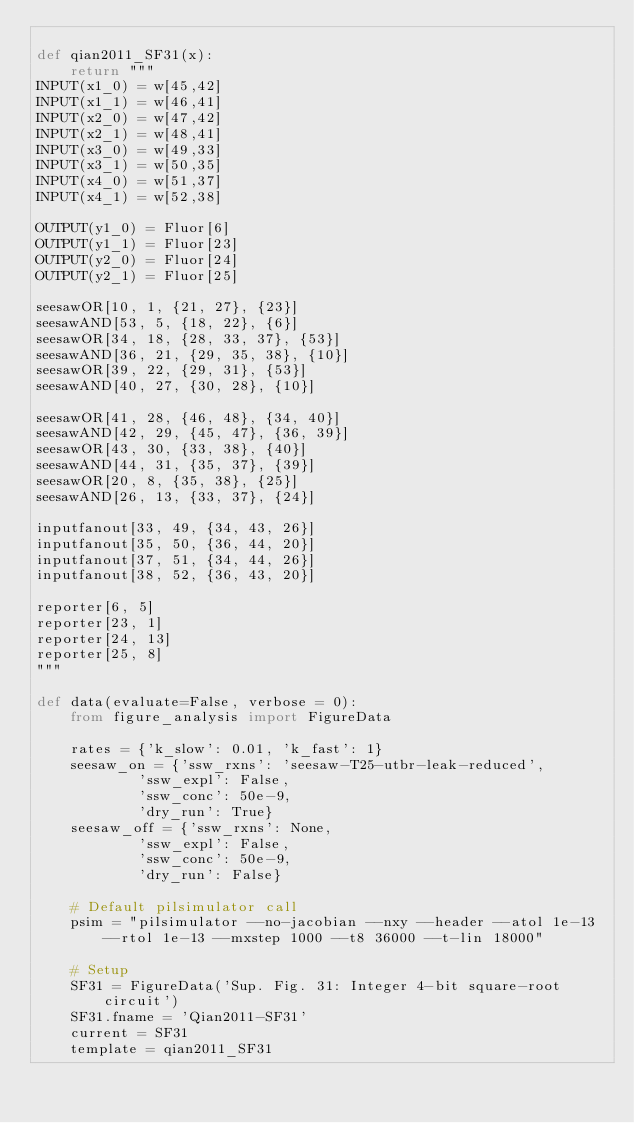Convert code to text. <code><loc_0><loc_0><loc_500><loc_500><_Python_>
def qian2011_SF31(x):
    return """
INPUT(x1_0) = w[45,42]
INPUT(x1_1) = w[46,41]
INPUT(x2_0) = w[47,42]
INPUT(x2_1) = w[48,41]
INPUT(x3_0) = w[49,33]
INPUT(x3_1) = w[50,35]
INPUT(x4_0) = w[51,37]
INPUT(x4_1) = w[52,38]

OUTPUT(y1_0) = Fluor[6]
OUTPUT(y1_1) = Fluor[23]
OUTPUT(y2_0) = Fluor[24]
OUTPUT(y2_1) = Fluor[25]

seesawOR[10, 1, {21, 27}, {23}]
seesawAND[53, 5, {18, 22}, {6}]
seesawOR[34, 18, {28, 33, 37}, {53}]
seesawAND[36, 21, {29, 35, 38}, {10}]
seesawOR[39, 22, {29, 31}, {53}]
seesawAND[40, 27, {30, 28}, {10}]

seesawOR[41, 28, {46, 48}, {34, 40}]
seesawAND[42, 29, {45, 47}, {36, 39}]
seesawOR[43, 30, {33, 38}, {40}]
seesawAND[44, 31, {35, 37}, {39}]
seesawOR[20, 8, {35, 38}, {25}]
seesawAND[26, 13, {33, 37}, {24}]

inputfanout[33, 49, {34, 43, 26}]
inputfanout[35, 50, {36, 44, 20}]
inputfanout[37, 51, {34, 44, 26}]
inputfanout[38, 52, {36, 43, 20}]

reporter[6, 5]
reporter[23, 1]
reporter[24, 13]
reporter[25, 8]
"""

def data(evaluate=False, verbose = 0):
    from figure_analysis import FigureData

    rates = {'k_slow': 0.01, 'k_fast': 1}
    seesaw_on = {'ssw_rxns': 'seesaw-T25-utbr-leak-reduced',
            'ssw_expl': False,
            'ssw_conc': 50e-9,
            'dry_run': True}
    seesaw_off = {'ssw_rxns': None,
            'ssw_expl': False,
            'ssw_conc': 50e-9,
            'dry_run': False}

    # Default pilsimulator call
    psim = "pilsimulator --no-jacobian --nxy --header --atol 1e-13 --rtol 1e-13 --mxstep 1000 --t8 36000 --t-lin 18000"

    # Setup
    SF31 = FigureData('Sup. Fig. 31: Integer 4-bit square-root circuit')
    SF31.fname = 'Qian2011-SF31'
    current = SF31
    template = qian2011_SF31</code> 